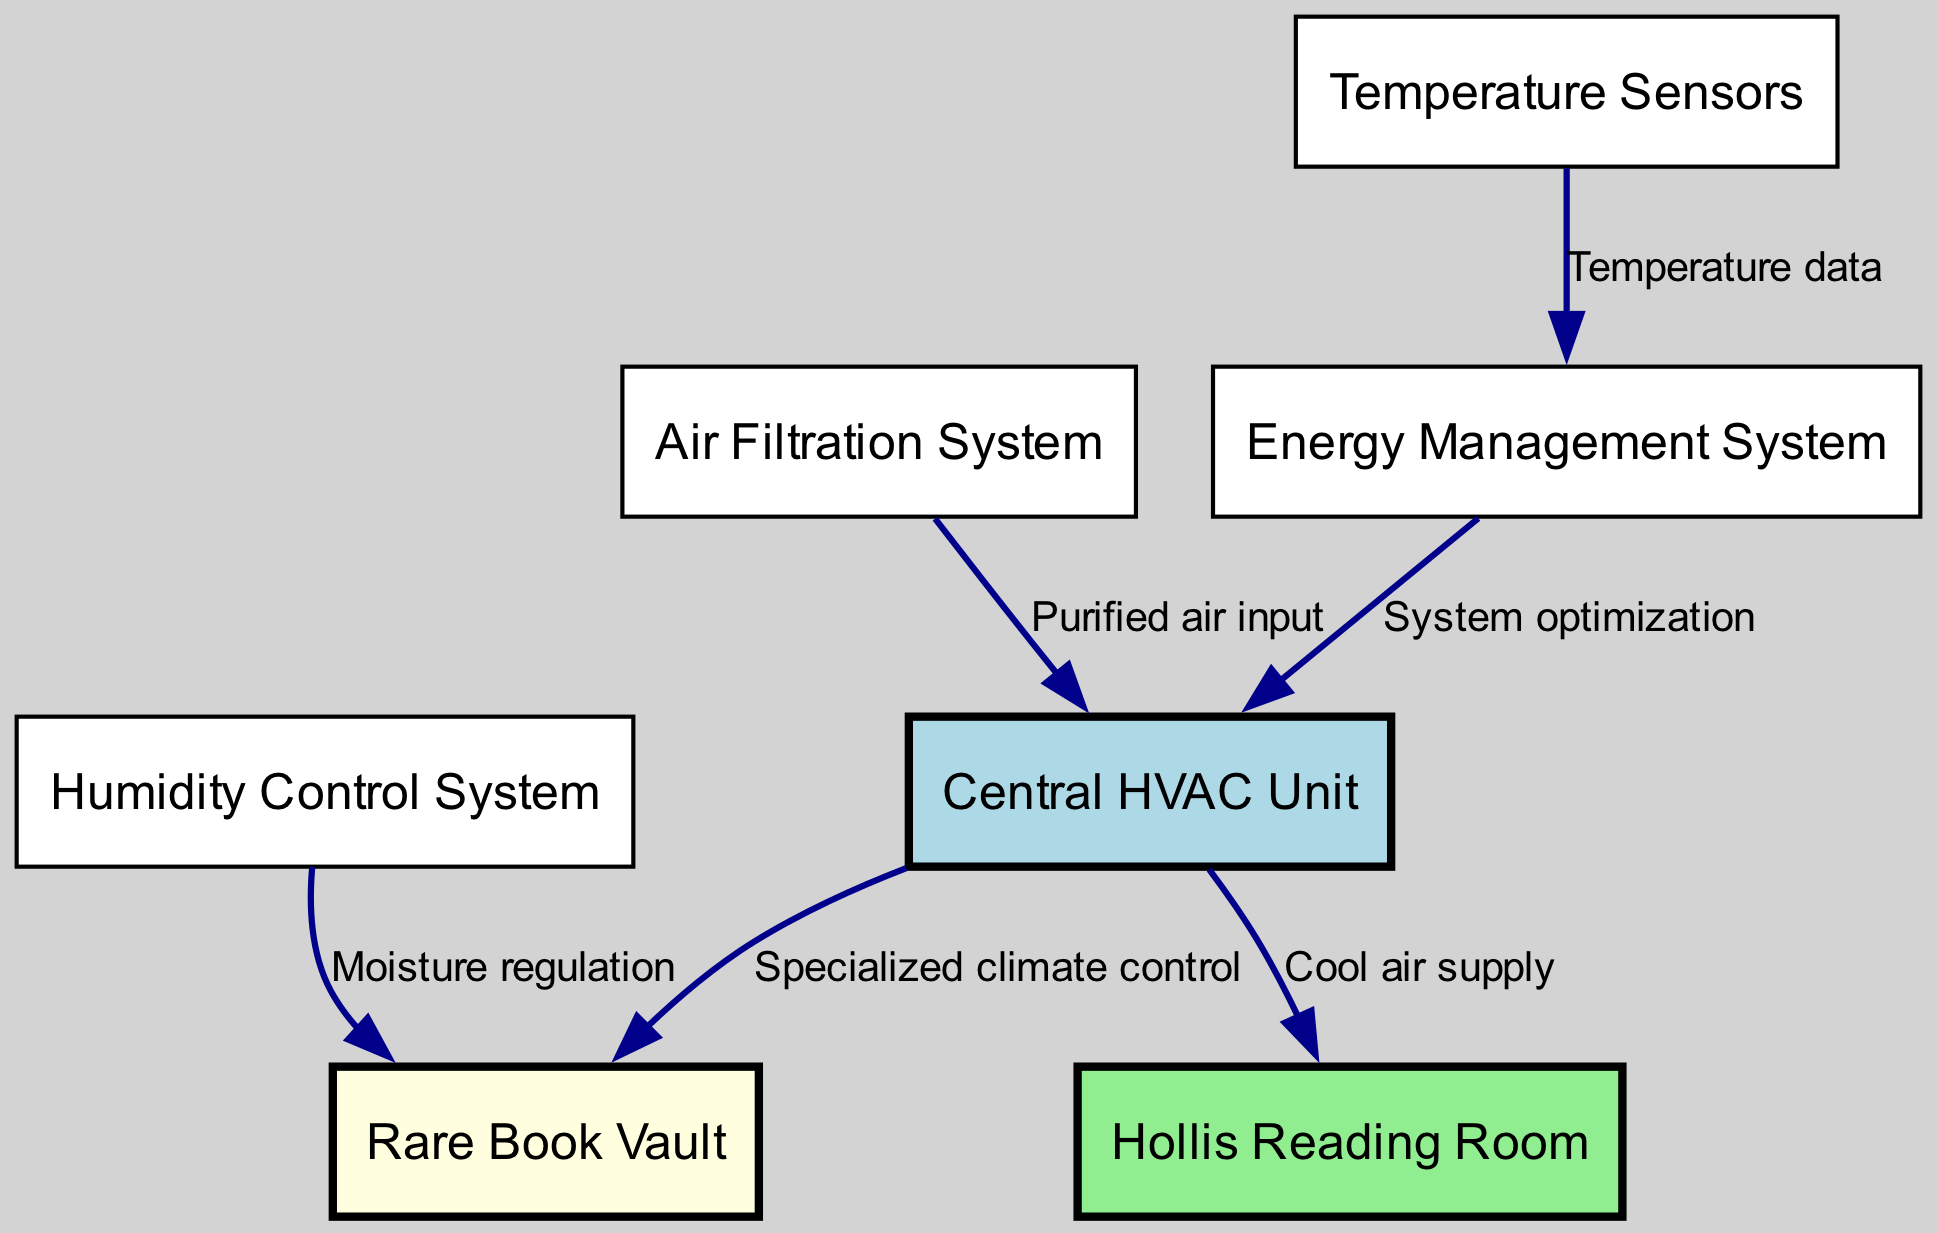What is the total number of nodes in the diagram? The diagram lists 7 nodes, which are: Central HVAC Unit, Hollis Reading Room, Rare Book Vault, Humidity Control System, Temperature Sensors, Air Filtration System, and Energy Management System.
Answer: 7 Which node supplies cool air to the Hollis Reading Room? The edge labeled "Cool air supply" connects the Central HVAC Unit (node 1) to the Hollis Reading Room (node 2). Therefore, the Central HVAC Unit supplies cool air to the Hollis Reading Room.
Answer: Central HVAC Unit What is the function of the Humidity Control System? The Humidity Control System (node 4) has an edge labeled "Moisture regulation" directed towards the Rare Book Vault (node 3). This indicates its function to regulate moisture in the Rare Book Vault.
Answer: Moisture regulation How many edges connect to the Central HVAC Unit? After analyzing the diagram, there are 3 edges connected to the Central HVAC Unit: one to the Hollis Reading Room, one to the Rare Book Vault, and one from the Air Filtration System.
Answer: 3 Which component provides temperature data to the Energy Management System? The edge labeled "Temperature data" originates from the Temperature Sensors (node 5) and points to the Energy Management System (node 7). This means the Temperature Sensors provide temperature data to the Energy Management System.
Answer: Temperature Sensors Which node receives purified air input? The edge labeled "Purified air input" connects the Air Filtration System (node 6) to the Central HVAC Unit (node 1). Therefore, the Central HVAC Unit receives purified air input.
Answer: Central HVAC Unit What system optimizes the Central HVAC Unit? The edge labeled "System optimization" is directed from the Energy Management System (node 7) to the Central HVAC Unit (node 1), indicating that the Energy Management System optimizes the Central HVAC Unit.
Answer: Energy Management System Which room is specifically designed for temperature and humidity control? The Rare Book Vault (node 3) is served by the Central HVAC Unit for climate control and receives moisture regulation from the Humidity Control System, indicating its specialty in temperature and humidity control.
Answer: Rare Book Vault 